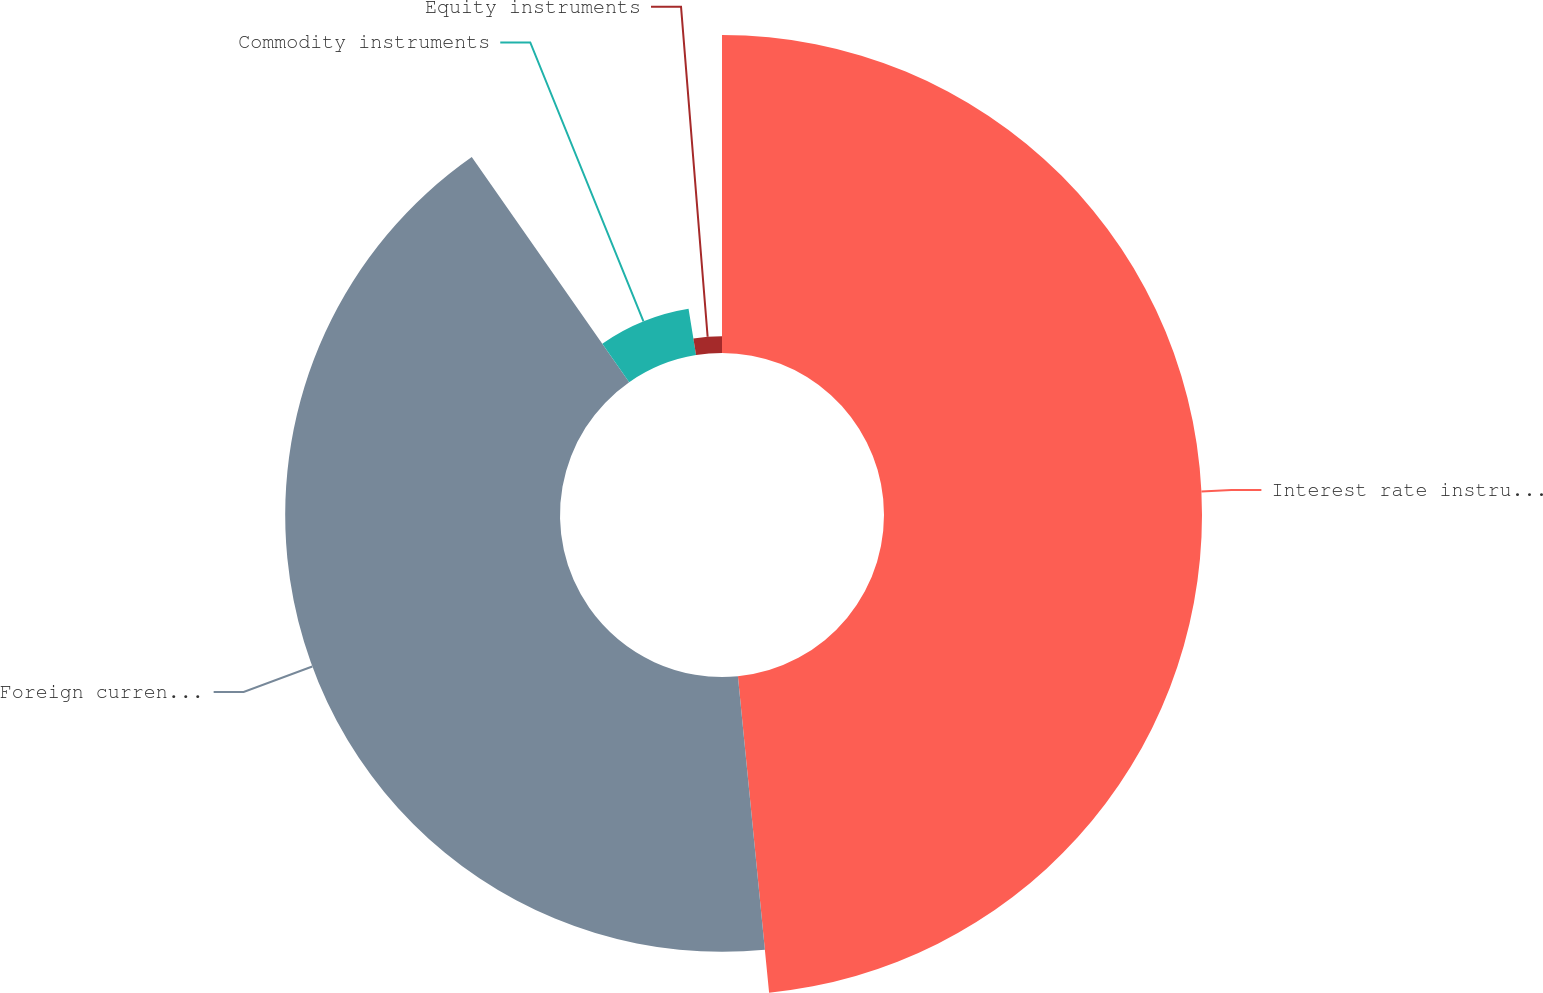Convert chart to OTSL. <chart><loc_0><loc_0><loc_500><loc_500><pie_chart><fcel>Interest rate instruments<fcel>Foreign currency instruments<fcel>Commodity instruments<fcel>Equity instruments<nl><fcel>48.44%<fcel>41.86%<fcel>7.15%<fcel>2.56%<nl></chart> 